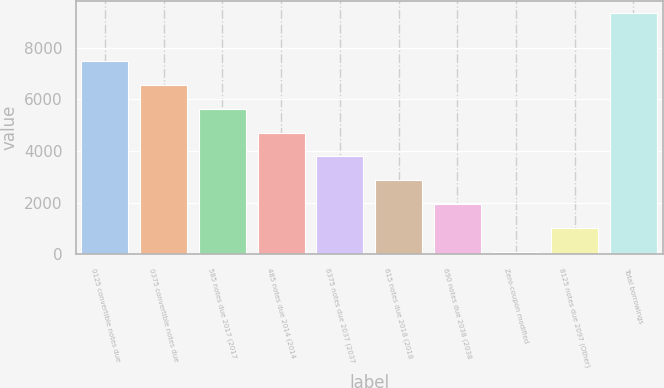<chart> <loc_0><loc_0><loc_500><loc_500><bar_chart><fcel>0125 convertible notes due<fcel>0375 convertible notes due<fcel>585 notes due 2017 (2017<fcel>485 notes due 2014 (2014<fcel>6375 notes due 2037 (2037<fcel>615 notes due 2018 (2018<fcel>690 notes due 2038 (2038<fcel>Zero-coupon modified<fcel>8125 notes due 2097 (Other)<fcel>Total borrowings<nl><fcel>7497.8<fcel>6570.7<fcel>5643.6<fcel>4716.5<fcel>3789.4<fcel>2862.3<fcel>1935.2<fcel>81<fcel>1008.1<fcel>9352<nl></chart> 